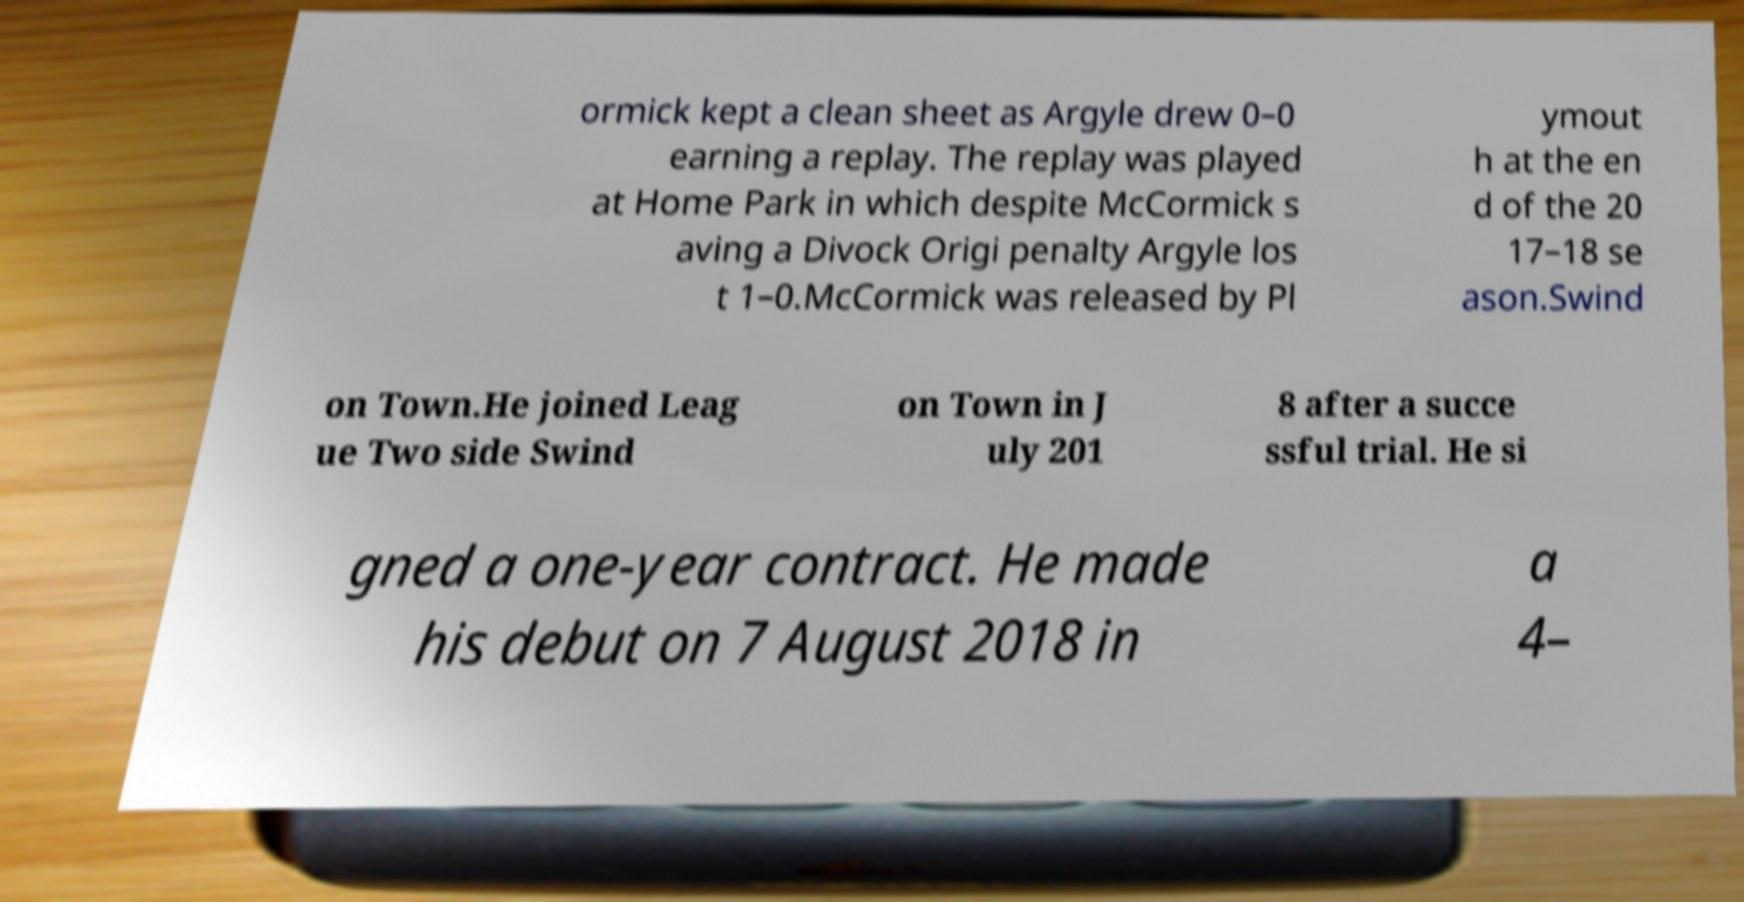I need the written content from this picture converted into text. Can you do that? ormick kept a clean sheet as Argyle drew 0–0 earning a replay. The replay was played at Home Park in which despite McCormick s aving a Divock Origi penalty Argyle los t 1–0.McCormick was released by Pl ymout h at the en d of the 20 17–18 se ason.Swind on Town.He joined Leag ue Two side Swind on Town in J uly 201 8 after a succe ssful trial. He si gned a one-year contract. He made his debut on 7 August 2018 in a 4– 